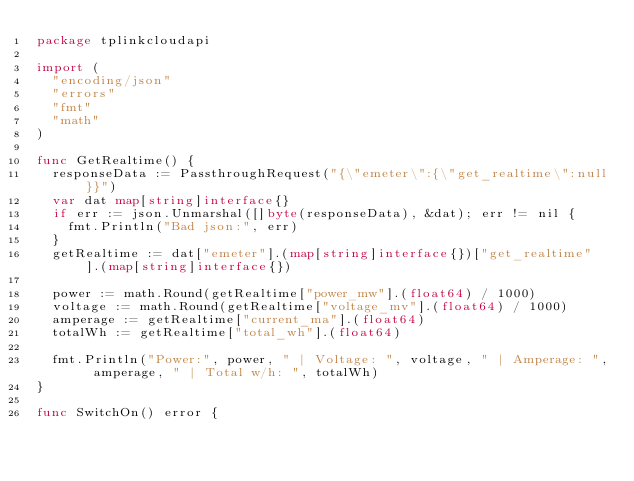<code> <loc_0><loc_0><loc_500><loc_500><_Go_>package tplinkcloudapi

import (
	"encoding/json"
	"errors"
	"fmt"
	"math"
)

func GetRealtime() {
	responseData := PassthroughRequest("{\"emeter\":{\"get_realtime\":null}}")
	var dat map[string]interface{}
	if err := json.Unmarshal([]byte(responseData), &dat); err != nil {
		fmt.Println("Bad json:", err)
	}
	getRealtime := dat["emeter"].(map[string]interface{})["get_realtime"].(map[string]interface{})

	power := math.Round(getRealtime["power_mw"].(float64) / 1000)
	voltage := math.Round(getRealtime["voltage_mv"].(float64) / 1000)
	amperage := getRealtime["current_ma"].(float64)
	totalWh := getRealtime["total_wh"].(float64)

	fmt.Println("Power:", power, " | Voltage: ", voltage, " | Amperage: ", amperage, " | Total w/h: ", totalWh)
}

func SwitchOn() error {</code> 